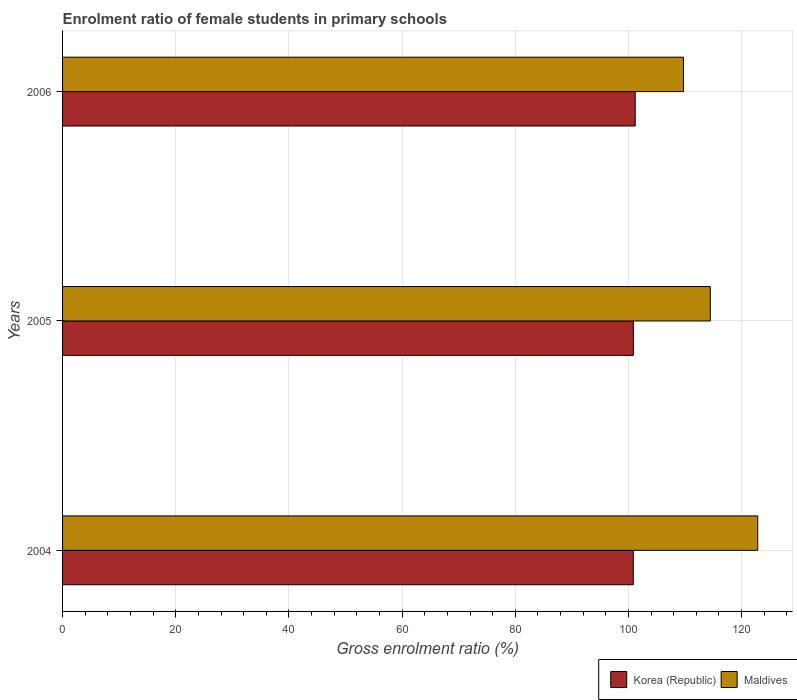How many groups of bars are there?
Give a very brief answer. 3. Are the number of bars on each tick of the Y-axis equal?
Offer a terse response. Yes. What is the enrolment ratio of female students in primary schools in Maldives in 2005?
Make the answer very short. 114.46. Across all years, what is the maximum enrolment ratio of female students in primary schools in Korea (Republic)?
Your answer should be very brief. 101.19. Across all years, what is the minimum enrolment ratio of female students in primary schools in Korea (Republic)?
Keep it short and to the point. 100.85. What is the total enrolment ratio of female students in primary schools in Maldives in the graph?
Ensure brevity in your answer.  347.03. What is the difference between the enrolment ratio of female students in primary schools in Maldives in 2004 and that in 2005?
Your answer should be compact. 8.39. What is the difference between the enrolment ratio of female students in primary schools in Maldives in 2004 and the enrolment ratio of female students in primary schools in Korea (Republic) in 2005?
Your response must be concise. 21.98. What is the average enrolment ratio of female students in primary schools in Maldives per year?
Your response must be concise. 115.68. In the year 2006, what is the difference between the enrolment ratio of female students in primary schools in Korea (Republic) and enrolment ratio of female students in primary schools in Maldives?
Offer a terse response. -8.53. In how many years, is the enrolment ratio of female students in primary schools in Maldives greater than 52 %?
Provide a short and direct response. 3. What is the ratio of the enrolment ratio of female students in primary schools in Korea (Republic) in 2005 to that in 2006?
Give a very brief answer. 1. Is the difference between the enrolment ratio of female students in primary schools in Korea (Republic) in 2004 and 2005 greater than the difference between the enrolment ratio of female students in primary schools in Maldives in 2004 and 2005?
Keep it short and to the point. No. What is the difference between the highest and the second highest enrolment ratio of female students in primary schools in Maldives?
Provide a short and direct response. 8.39. What is the difference between the highest and the lowest enrolment ratio of female students in primary schools in Korea (Republic)?
Your response must be concise. 0.34. In how many years, is the enrolment ratio of female students in primary schools in Maldives greater than the average enrolment ratio of female students in primary schools in Maldives taken over all years?
Offer a very short reply. 1. Is the sum of the enrolment ratio of female students in primary schools in Maldives in 2004 and 2005 greater than the maximum enrolment ratio of female students in primary schools in Korea (Republic) across all years?
Keep it short and to the point. Yes. What does the 2nd bar from the top in 2006 represents?
Keep it short and to the point. Korea (Republic). What does the 1st bar from the bottom in 2006 represents?
Your answer should be very brief. Korea (Republic). How many years are there in the graph?
Your answer should be very brief. 3. What is the difference between two consecutive major ticks on the X-axis?
Your response must be concise. 20. Are the values on the major ticks of X-axis written in scientific E-notation?
Make the answer very short. No. How are the legend labels stacked?
Your answer should be very brief. Horizontal. What is the title of the graph?
Offer a terse response. Enrolment ratio of female students in primary schools. What is the Gross enrolment ratio (%) in Korea (Republic) in 2004?
Offer a terse response. 100.85. What is the Gross enrolment ratio (%) in Maldives in 2004?
Your answer should be very brief. 122.85. What is the Gross enrolment ratio (%) in Korea (Republic) in 2005?
Offer a terse response. 100.87. What is the Gross enrolment ratio (%) of Maldives in 2005?
Give a very brief answer. 114.46. What is the Gross enrolment ratio (%) of Korea (Republic) in 2006?
Your response must be concise. 101.19. What is the Gross enrolment ratio (%) in Maldives in 2006?
Keep it short and to the point. 109.73. Across all years, what is the maximum Gross enrolment ratio (%) of Korea (Republic)?
Provide a succinct answer. 101.19. Across all years, what is the maximum Gross enrolment ratio (%) of Maldives?
Your response must be concise. 122.85. Across all years, what is the minimum Gross enrolment ratio (%) of Korea (Republic)?
Make the answer very short. 100.85. Across all years, what is the minimum Gross enrolment ratio (%) of Maldives?
Offer a terse response. 109.73. What is the total Gross enrolment ratio (%) in Korea (Republic) in the graph?
Keep it short and to the point. 302.92. What is the total Gross enrolment ratio (%) of Maldives in the graph?
Your response must be concise. 347.03. What is the difference between the Gross enrolment ratio (%) in Korea (Republic) in 2004 and that in 2005?
Give a very brief answer. -0.02. What is the difference between the Gross enrolment ratio (%) of Maldives in 2004 and that in 2005?
Provide a succinct answer. 8.39. What is the difference between the Gross enrolment ratio (%) in Korea (Republic) in 2004 and that in 2006?
Ensure brevity in your answer.  -0.34. What is the difference between the Gross enrolment ratio (%) in Maldives in 2004 and that in 2006?
Provide a succinct answer. 13.12. What is the difference between the Gross enrolment ratio (%) of Korea (Republic) in 2005 and that in 2006?
Make the answer very short. -0.32. What is the difference between the Gross enrolment ratio (%) of Maldives in 2005 and that in 2006?
Ensure brevity in your answer.  4.73. What is the difference between the Gross enrolment ratio (%) in Korea (Republic) in 2004 and the Gross enrolment ratio (%) in Maldives in 2005?
Ensure brevity in your answer.  -13.6. What is the difference between the Gross enrolment ratio (%) in Korea (Republic) in 2004 and the Gross enrolment ratio (%) in Maldives in 2006?
Your answer should be very brief. -8.87. What is the difference between the Gross enrolment ratio (%) in Korea (Republic) in 2005 and the Gross enrolment ratio (%) in Maldives in 2006?
Your answer should be compact. -8.86. What is the average Gross enrolment ratio (%) in Korea (Republic) per year?
Offer a terse response. 100.97. What is the average Gross enrolment ratio (%) of Maldives per year?
Give a very brief answer. 115.68. In the year 2004, what is the difference between the Gross enrolment ratio (%) of Korea (Republic) and Gross enrolment ratio (%) of Maldives?
Provide a succinct answer. -21.99. In the year 2005, what is the difference between the Gross enrolment ratio (%) of Korea (Republic) and Gross enrolment ratio (%) of Maldives?
Make the answer very short. -13.59. In the year 2006, what is the difference between the Gross enrolment ratio (%) in Korea (Republic) and Gross enrolment ratio (%) in Maldives?
Your answer should be compact. -8.53. What is the ratio of the Gross enrolment ratio (%) of Maldives in 2004 to that in 2005?
Provide a succinct answer. 1.07. What is the ratio of the Gross enrolment ratio (%) of Korea (Republic) in 2004 to that in 2006?
Ensure brevity in your answer.  1. What is the ratio of the Gross enrolment ratio (%) of Maldives in 2004 to that in 2006?
Your answer should be very brief. 1.12. What is the ratio of the Gross enrolment ratio (%) of Korea (Republic) in 2005 to that in 2006?
Keep it short and to the point. 1. What is the ratio of the Gross enrolment ratio (%) of Maldives in 2005 to that in 2006?
Offer a very short reply. 1.04. What is the difference between the highest and the second highest Gross enrolment ratio (%) of Korea (Republic)?
Your answer should be compact. 0.32. What is the difference between the highest and the second highest Gross enrolment ratio (%) in Maldives?
Ensure brevity in your answer.  8.39. What is the difference between the highest and the lowest Gross enrolment ratio (%) in Korea (Republic)?
Your response must be concise. 0.34. What is the difference between the highest and the lowest Gross enrolment ratio (%) in Maldives?
Your response must be concise. 13.12. 